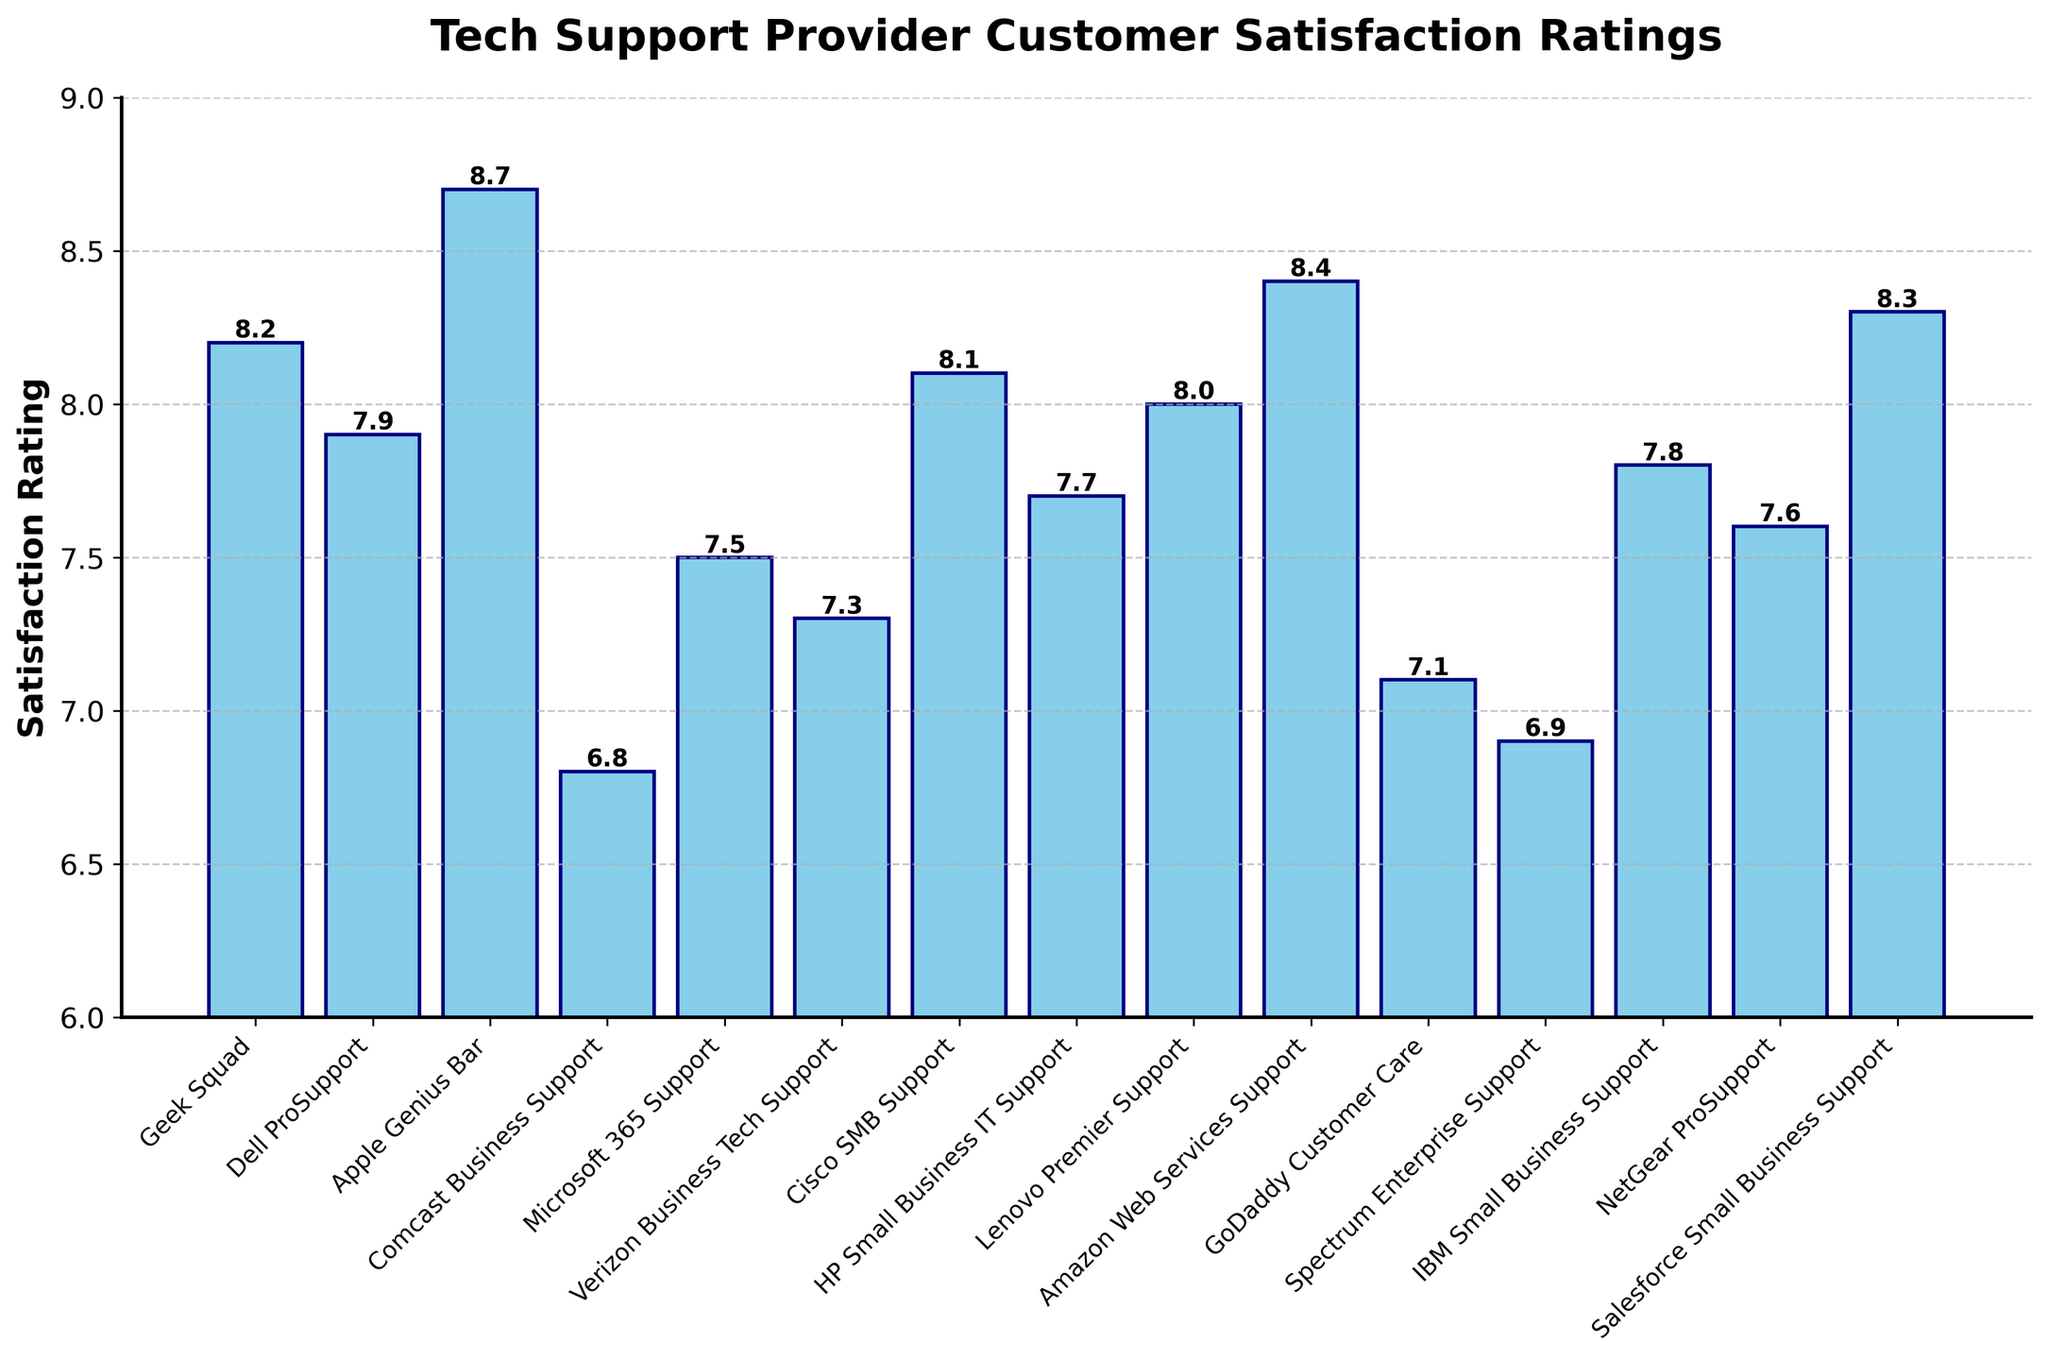Which tech support provider has the highest customer satisfaction rating? To find the highest customer satisfaction rating, look for the tallest bar in the chart. The tallest bar represents Apple Genius Bar with a rating of 8.7.
Answer: Apple Genius Bar Which tech support provider has the lowest customer satisfaction rating? To identify the lowest customer satisfaction rating, look for the shortest bar in the chart. The shortest bar represents Comcast Business Support with a rating of 6.8.
Answer: Comcast Business Support What is the difference in satisfaction rating between Amazon Web Services Support and IBM Small Business Support? The rating for Amazon Web Services Support is 8.4 and for IBM Small Business Support is 7.8. Subtracting the two gives 8.4 - 7.8 = 0.6.
Answer: 0.6 Which tech support providers have a satisfaction rating higher than 8.0? To find providers with ratings higher than 8.0, identify bars taller than the 8.0 mark on the y-axis. These are Geek Squad (8.2), Apple Genius Bar (8.7), Cisco SMB Support (8.1), Amazon Web Services Support (8.4), and Salesforce Small Business Support (8.3).
Answer: Geek Squad, Apple Genius Bar, Cisco SMB Support, Amazon Web Services Support, Salesforce Small Business Support What is the combined average satisfaction rating of Dell ProSupport, Microsoft 365 Support, and HP Small Business IT Support? The ratings are Dell ProSupport (7.9), Microsoft 365 Support (7.5), and HP Small Business IT Support (7.7). Adding the ratings gives 7.9 + 7.5 + 7.7 = 23.1. Dividing by 3 yields an average of 23.1 / 3 = 7.7.
Answer: 7.7 How many tech support providers have a satisfaction rating below 7.0? To count providers below a 7.0 rating, look for bars shorter than the 7.0 mark on the y-axis. These are Comcast Business Support (6.8) and Spectrum Enterprise Support (6.9). There are 2 such providers.
Answer: 2 Is the satisfaction rating of Microsoft 365 Support greater than that of Lenovo Premier Support? The rating for Microsoft 365 Support is 7.5 and for Lenovo Premier Support is 8.0. Since 7.5 is less than 8.0, the rating of Microsoft 365 Support is not greater.
Answer: No What is the median satisfaction rating among all the tech support providers? To find the median rating, list all the ratings in ascending order: 6.8, 6.9, 7.1, 7.3, 7.5, 7.6, 7.7, 7.8, 7.9, 8.0, 8.1, 8.2, 8.3, 8.4, 8.7. The middle value is the 8th value: 7.8.
Answer: 7.8 What is the range of customer satisfaction ratings for the tech support providers? The range is calculated by subtracting the lowest rating from the highest rating. The highest rating is 8.7 (Apple Genius Bar) and the lowest is 6.8 (Comcast Business Support). So, 8.7 - 6.8 = 1.9.
Answer: 1.9 